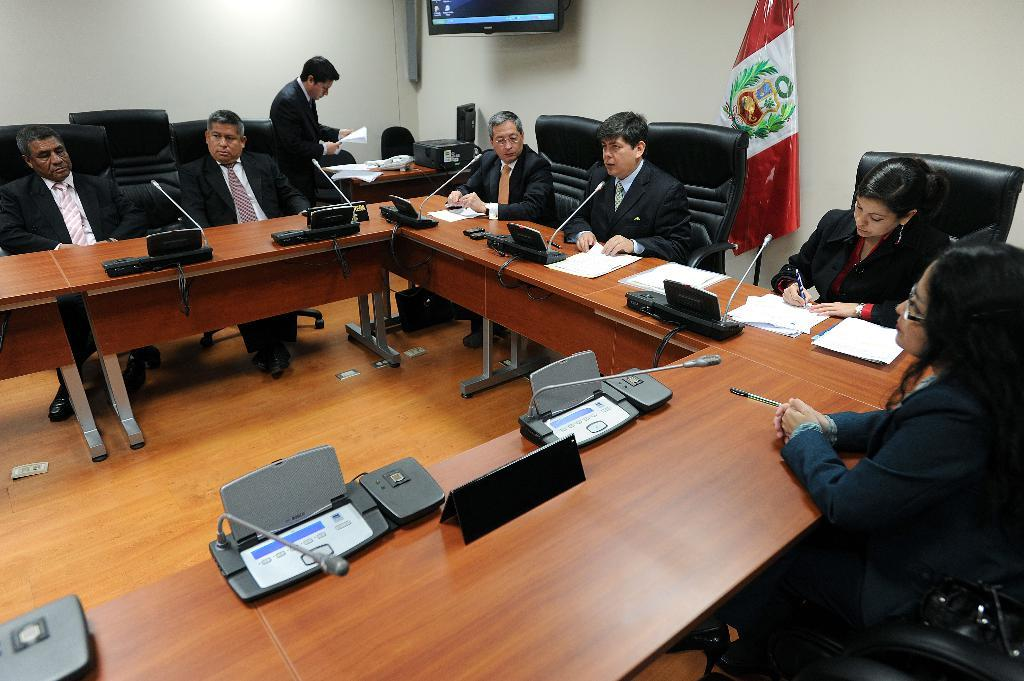What are the people in the image doing? The people in the image are sitting on chairs. What type of seating is also present in the image? There are wooden benches in the image. What type of objects can be seen that are typically used for communication or entertainment? Electronic gadgets are visible in the image. What symbol or emblem can be seen in the image? There is a flag in the image. What type of structure is present in the background of the image? There is a wall in the image. What type of rice is being served on the wooden benches in the image? There is no rice present in the image; it features people sitting on chairs and wooden benches, electronic gadgets, a flag, and a wall. What color is the underwear of the person sitting on the chair in the image? There is no information about the person's underwear in the image, as it only shows people sitting on chairs and wooden benches, electronic gadgets, a flag, and a wall. 